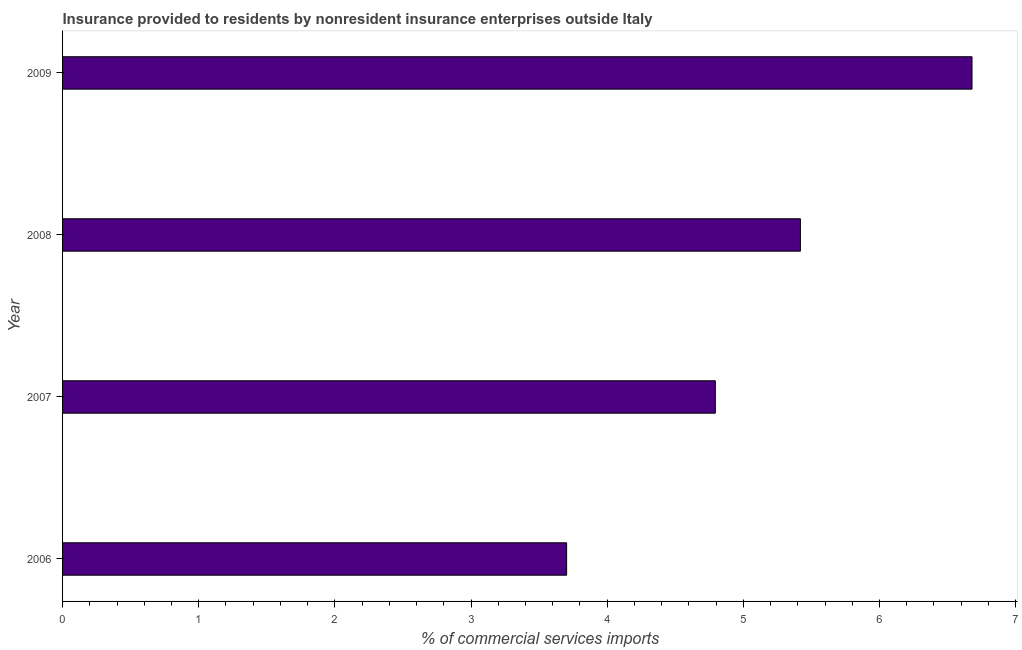Does the graph contain grids?
Provide a succinct answer. No. What is the title of the graph?
Keep it short and to the point. Insurance provided to residents by nonresident insurance enterprises outside Italy. What is the label or title of the X-axis?
Keep it short and to the point. % of commercial services imports. What is the insurance provided by non-residents in 2009?
Offer a terse response. 6.68. Across all years, what is the maximum insurance provided by non-residents?
Ensure brevity in your answer.  6.68. Across all years, what is the minimum insurance provided by non-residents?
Ensure brevity in your answer.  3.7. What is the sum of the insurance provided by non-residents?
Ensure brevity in your answer.  20.59. What is the difference between the insurance provided by non-residents in 2006 and 2008?
Offer a very short reply. -1.72. What is the average insurance provided by non-residents per year?
Give a very brief answer. 5.15. What is the median insurance provided by non-residents?
Make the answer very short. 5.11. What is the ratio of the insurance provided by non-residents in 2006 to that in 2007?
Offer a very short reply. 0.77. What is the difference between the highest and the second highest insurance provided by non-residents?
Your answer should be compact. 1.26. What is the difference between the highest and the lowest insurance provided by non-residents?
Provide a succinct answer. 2.98. In how many years, is the insurance provided by non-residents greater than the average insurance provided by non-residents taken over all years?
Provide a succinct answer. 2. What is the % of commercial services imports of 2006?
Your answer should be very brief. 3.7. What is the % of commercial services imports in 2007?
Keep it short and to the point. 4.79. What is the % of commercial services imports of 2008?
Give a very brief answer. 5.42. What is the % of commercial services imports in 2009?
Your answer should be compact. 6.68. What is the difference between the % of commercial services imports in 2006 and 2007?
Offer a very short reply. -1.09. What is the difference between the % of commercial services imports in 2006 and 2008?
Provide a succinct answer. -1.72. What is the difference between the % of commercial services imports in 2006 and 2009?
Make the answer very short. -2.98. What is the difference between the % of commercial services imports in 2007 and 2008?
Your answer should be compact. -0.62. What is the difference between the % of commercial services imports in 2007 and 2009?
Your response must be concise. -1.89. What is the difference between the % of commercial services imports in 2008 and 2009?
Your response must be concise. -1.26. What is the ratio of the % of commercial services imports in 2006 to that in 2007?
Your answer should be very brief. 0.77. What is the ratio of the % of commercial services imports in 2006 to that in 2008?
Provide a succinct answer. 0.68. What is the ratio of the % of commercial services imports in 2006 to that in 2009?
Offer a terse response. 0.55. What is the ratio of the % of commercial services imports in 2007 to that in 2008?
Provide a short and direct response. 0.89. What is the ratio of the % of commercial services imports in 2007 to that in 2009?
Make the answer very short. 0.72. What is the ratio of the % of commercial services imports in 2008 to that in 2009?
Provide a succinct answer. 0.81. 